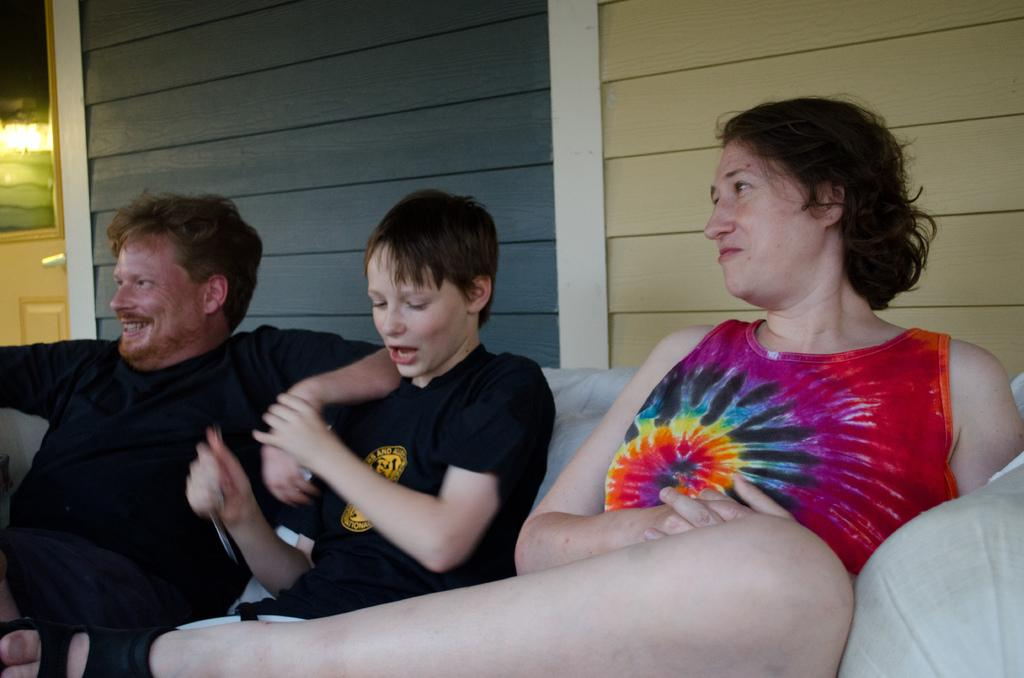Where is the woman located in the image? The woman is sitting on the sofa on the right side of the image. Who is sitting beside the woman? There are two persons sitting beside the woman. What are the two persons doing? The two persons are laughing. What color are the t-shirts worn by the two persons? The two persons are wearing black color t-shirts. Can you see any fog or cars in the image? No, there is no fog or cars present in the image. 